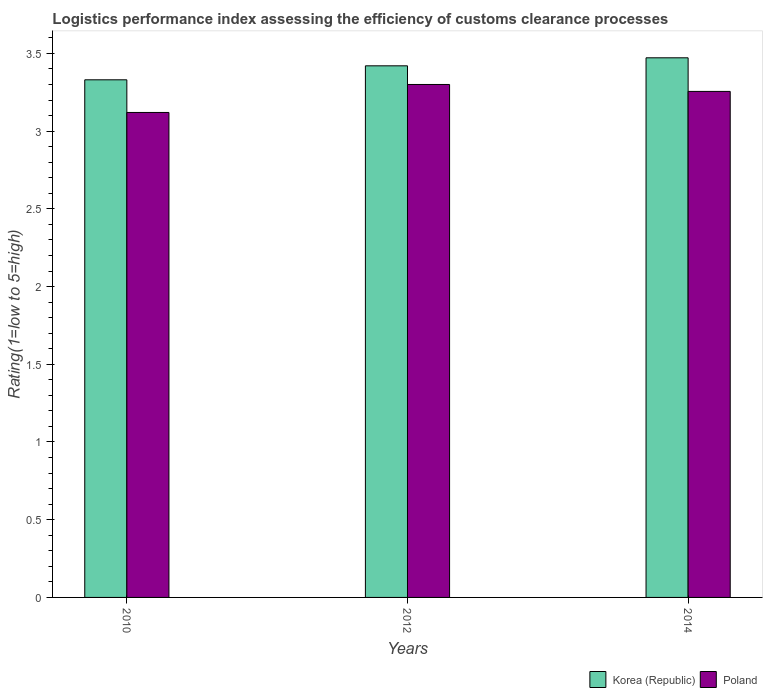Are the number of bars on each tick of the X-axis equal?
Provide a short and direct response. Yes. In how many cases, is the number of bars for a given year not equal to the number of legend labels?
Keep it short and to the point. 0. What is the Logistic performance index in Korea (Republic) in 2014?
Offer a very short reply. 3.47. Across all years, what is the maximum Logistic performance index in Korea (Republic)?
Offer a very short reply. 3.47. Across all years, what is the minimum Logistic performance index in Poland?
Your response must be concise. 3.12. In which year was the Logistic performance index in Poland minimum?
Provide a short and direct response. 2010. What is the total Logistic performance index in Korea (Republic) in the graph?
Offer a very short reply. 10.22. What is the difference between the Logistic performance index in Korea (Republic) in 2010 and that in 2012?
Give a very brief answer. -0.09. What is the difference between the Logistic performance index in Korea (Republic) in 2014 and the Logistic performance index in Poland in 2012?
Ensure brevity in your answer.  0.17. What is the average Logistic performance index in Korea (Republic) per year?
Your answer should be compact. 3.41. In the year 2012, what is the difference between the Logistic performance index in Korea (Republic) and Logistic performance index in Poland?
Make the answer very short. 0.12. What is the ratio of the Logistic performance index in Korea (Republic) in 2010 to that in 2014?
Your response must be concise. 0.96. Is the difference between the Logistic performance index in Korea (Republic) in 2010 and 2012 greater than the difference between the Logistic performance index in Poland in 2010 and 2012?
Keep it short and to the point. Yes. What is the difference between the highest and the second highest Logistic performance index in Poland?
Ensure brevity in your answer.  0.04. What is the difference between the highest and the lowest Logistic performance index in Korea (Republic)?
Offer a very short reply. 0.14. In how many years, is the Logistic performance index in Korea (Republic) greater than the average Logistic performance index in Korea (Republic) taken over all years?
Ensure brevity in your answer.  2. What does the 1st bar from the right in 2010 represents?
Offer a very short reply. Poland. How many bars are there?
Offer a terse response. 6. Does the graph contain any zero values?
Give a very brief answer. No. Does the graph contain grids?
Give a very brief answer. No. Where does the legend appear in the graph?
Offer a very short reply. Bottom right. How many legend labels are there?
Make the answer very short. 2. How are the legend labels stacked?
Make the answer very short. Horizontal. What is the title of the graph?
Your response must be concise. Logistics performance index assessing the efficiency of customs clearance processes. Does "Pakistan" appear as one of the legend labels in the graph?
Your response must be concise. No. What is the label or title of the Y-axis?
Your answer should be compact. Rating(1=low to 5=high). What is the Rating(1=low to 5=high) in Korea (Republic) in 2010?
Offer a very short reply. 3.33. What is the Rating(1=low to 5=high) in Poland in 2010?
Provide a short and direct response. 3.12. What is the Rating(1=low to 5=high) in Korea (Republic) in 2012?
Provide a succinct answer. 3.42. What is the Rating(1=low to 5=high) of Poland in 2012?
Keep it short and to the point. 3.3. What is the Rating(1=low to 5=high) of Korea (Republic) in 2014?
Provide a short and direct response. 3.47. What is the Rating(1=low to 5=high) in Poland in 2014?
Make the answer very short. 3.26. Across all years, what is the maximum Rating(1=low to 5=high) in Korea (Republic)?
Provide a short and direct response. 3.47. Across all years, what is the maximum Rating(1=low to 5=high) of Poland?
Ensure brevity in your answer.  3.3. Across all years, what is the minimum Rating(1=low to 5=high) of Korea (Republic)?
Your answer should be compact. 3.33. Across all years, what is the minimum Rating(1=low to 5=high) of Poland?
Your response must be concise. 3.12. What is the total Rating(1=low to 5=high) of Korea (Republic) in the graph?
Keep it short and to the point. 10.22. What is the total Rating(1=low to 5=high) of Poland in the graph?
Your answer should be compact. 9.68. What is the difference between the Rating(1=low to 5=high) in Korea (Republic) in 2010 and that in 2012?
Offer a terse response. -0.09. What is the difference between the Rating(1=low to 5=high) in Poland in 2010 and that in 2012?
Your response must be concise. -0.18. What is the difference between the Rating(1=low to 5=high) of Korea (Republic) in 2010 and that in 2014?
Provide a short and direct response. -0.14. What is the difference between the Rating(1=low to 5=high) of Poland in 2010 and that in 2014?
Keep it short and to the point. -0.14. What is the difference between the Rating(1=low to 5=high) in Korea (Republic) in 2012 and that in 2014?
Offer a very short reply. -0.05. What is the difference between the Rating(1=low to 5=high) in Poland in 2012 and that in 2014?
Give a very brief answer. 0.04. What is the difference between the Rating(1=low to 5=high) of Korea (Republic) in 2010 and the Rating(1=low to 5=high) of Poland in 2014?
Your response must be concise. 0.07. What is the difference between the Rating(1=low to 5=high) of Korea (Republic) in 2012 and the Rating(1=low to 5=high) of Poland in 2014?
Keep it short and to the point. 0.16. What is the average Rating(1=low to 5=high) of Korea (Republic) per year?
Ensure brevity in your answer.  3.41. What is the average Rating(1=low to 5=high) of Poland per year?
Give a very brief answer. 3.23. In the year 2010, what is the difference between the Rating(1=low to 5=high) of Korea (Republic) and Rating(1=low to 5=high) of Poland?
Offer a very short reply. 0.21. In the year 2012, what is the difference between the Rating(1=low to 5=high) of Korea (Republic) and Rating(1=low to 5=high) of Poland?
Ensure brevity in your answer.  0.12. In the year 2014, what is the difference between the Rating(1=low to 5=high) in Korea (Republic) and Rating(1=low to 5=high) in Poland?
Your answer should be very brief. 0.22. What is the ratio of the Rating(1=low to 5=high) in Korea (Republic) in 2010 to that in 2012?
Provide a short and direct response. 0.97. What is the ratio of the Rating(1=low to 5=high) of Poland in 2010 to that in 2012?
Provide a short and direct response. 0.95. What is the ratio of the Rating(1=low to 5=high) in Korea (Republic) in 2010 to that in 2014?
Give a very brief answer. 0.96. What is the ratio of the Rating(1=low to 5=high) of Poland in 2010 to that in 2014?
Offer a very short reply. 0.96. What is the ratio of the Rating(1=low to 5=high) in Korea (Republic) in 2012 to that in 2014?
Give a very brief answer. 0.99. What is the ratio of the Rating(1=low to 5=high) of Poland in 2012 to that in 2014?
Keep it short and to the point. 1.01. What is the difference between the highest and the second highest Rating(1=low to 5=high) of Korea (Republic)?
Ensure brevity in your answer.  0.05. What is the difference between the highest and the second highest Rating(1=low to 5=high) of Poland?
Offer a terse response. 0.04. What is the difference between the highest and the lowest Rating(1=low to 5=high) in Korea (Republic)?
Offer a terse response. 0.14. What is the difference between the highest and the lowest Rating(1=low to 5=high) of Poland?
Keep it short and to the point. 0.18. 